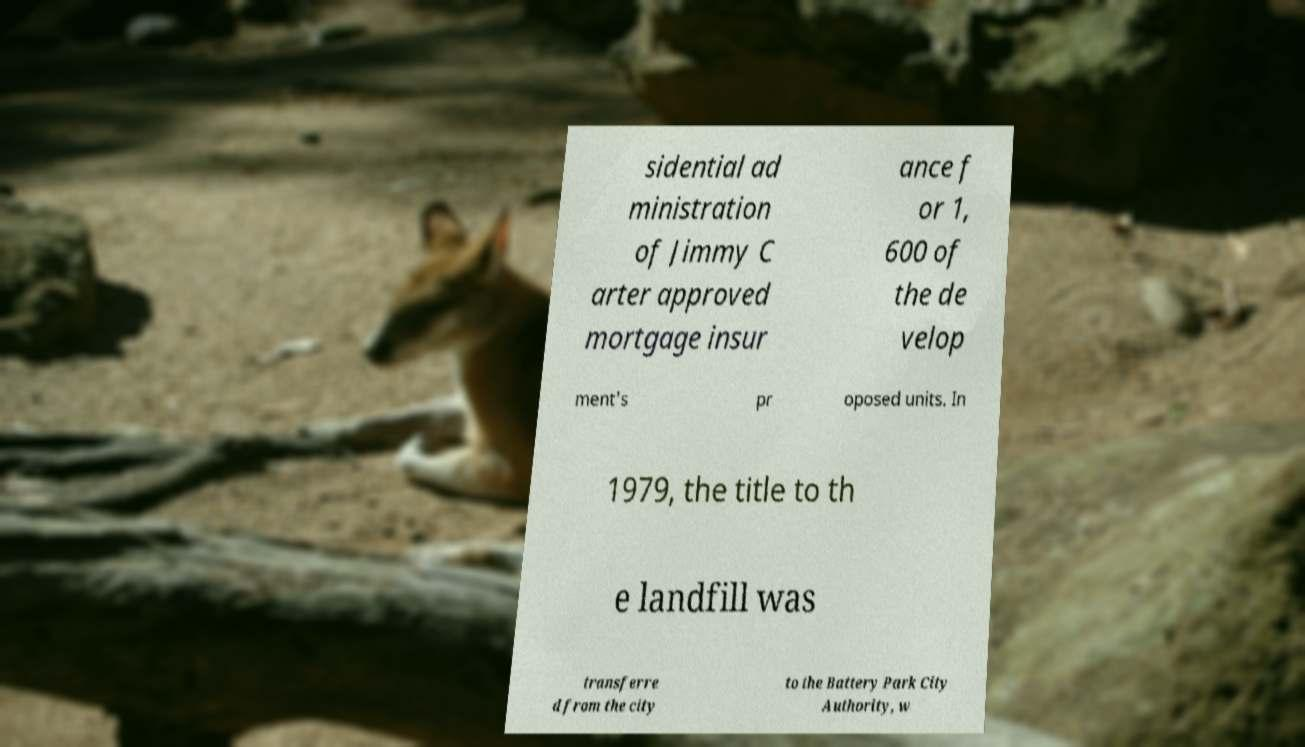For documentation purposes, I need the text within this image transcribed. Could you provide that? sidential ad ministration of Jimmy C arter approved mortgage insur ance f or 1, 600 of the de velop ment's pr oposed units. In 1979, the title to th e landfill was transferre d from the city to the Battery Park City Authority, w 